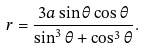Convert formula to latex. <formula><loc_0><loc_0><loc_500><loc_500>r = { \frac { 3 a \sin \theta \cos \theta } { \sin ^ { 3 } \theta + \cos ^ { 3 } \theta } } .</formula> 